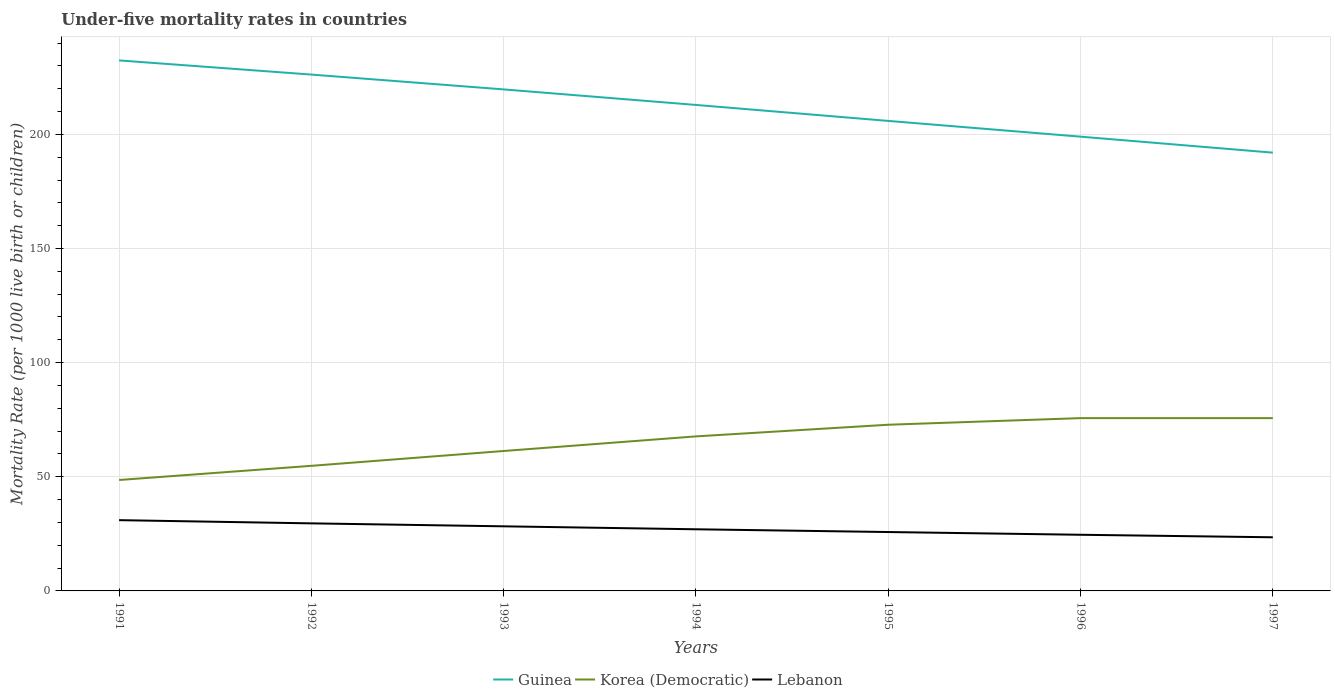How many different coloured lines are there?
Make the answer very short. 3. Does the line corresponding to Lebanon intersect with the line corresponding to Korea (Democratic)?
Provide a succinct answer. No. Across all years, what is the maximum under-five mortality rate in Korea (Democratic)?
Provide a succinct answer. 48.6. What is the total under-five mortality rate in Korea (Democratic) in the graph?
Offer a very short reply. -2.9. What is the difference between the highest and the second highest under-five mortality rate in Guinea?
Your answer should be compact. 40.4. How many years are there in the graph?
Your answer should be very brief. 7. What is the difference between two consecutive major ticks on the Y-axis?
Offer a terse response. 50. Does the graph contain grids?
Your response must be concise. Yes. How are the legend labels stacked?
Your answer should be very brief. Horizontal. What is the title of the graph?
Offer a very short reply. Under-five mortality rates in countries. Does "Cyprus" appear as one of the legend labels in the graph?
Keep it short and to the point. No. What is the label or title of the Y-axis?
Your response must be concise. Mortality Rate (per 1000 live birth or children). What is the Mortality Rate (per 1000 live birth or children) of Guinea in 1991?
Ensure brevity in your answer.  232.4. What is the Mortality Rate (per 1000 live birth or children) of Korea (Democratic) in 1991?
Make the answer very short. 48.6. What is the Mortality Rate (per 1000 live birth or children) of Guinea in 1992?
Provide a succinct answer. 226.2. What is the Mortality Rate (per 1000 live birth or children) of Korea (Democratic) in 1992?
Your answer should be very brief. 54.8. What is the Mortality Rate (per 1000 live birth or children) of Lebanon in 1992?
Provide a short and direct response. 29.6. What is the Mortality Rate (per 1000 live birth or children) of Guinea in 1993?
Make the answer very short. 219.7. What is the Mortality Rate (per 1000 live birth or children) of Korea (Democratic) in 1993?
Provide a succinct answer. 61.3. What is the Mortality Rate (per 1000 live birth or children) of Lebanon in 1993?
Provide a short and direct response. 28.3. What is the Mortality Rate (per 1000 live birth or children) in Guinea in 1994?
Provide a short and direct response. 212.9. What is the Mortality Rate (per 1000 live birth or children) in Korea (Democratic) in 1994?
Provide a short and direct response. 67.7. What is the Mortality Rate (per 1000 live birth or children) in Lebanon in 1994?
Keep it short and to the point. 27. What is the Mortality Rate (per 1000 live birth or children) in Guinea in 1995?
Your answer should be very brief. 205.9. What is the Mortality Rate (per 1000 live birth or children) in Korea (Democratic) in 1995?
Offer a terse response. 72.8. What is the Mortality Rate (per 1000 live birth or children) of Lebanon in 1995?
Ensure brevity in your answer.  25.8. What is the Mortality Rate (per 1000 live birth or children) of Guinea in 1996?
Offer a very short reply. 199. What is the Mortality Rate (per 1000 live birth or children) in Korea (Democratic) in 1996?
Offer a terse response. 75.7. What is the Mortality Rate (per 1000 live birth or children) of Lebanon in 1996?
Your answer should be very brief. 24.6. What is the Mortality Rate (per 1000 live birth or children) of Guinea in 1997?
Provide a succinct answer. 192. What is the Mortality Rate (per 1000 live birth or children) of Korea (Democratic) in 1997?
Provide a short and direct response. 75.7. What is the Mortality Rate (per 1000 live birth or children) in Lebanon in 1997?
Make the answer very short. 23.5. Across all years, what is the maximum Mortality Rate (per 1000 live birth or children) in Guinea?
Offer a terse response. 232.4. Across all years, what is the maximum Mortality Rate (per 1000 live birth or children) in Korea (Democratic)?
Your response must be concise. 75.7. Across all years, what is the maximum Mortality Rate (per 1000 live birth or children) in Lebanon?
Keep it short and to the point. 31. Across all years, what is the minimum Mortality Rate (per 1000 live birth or children) of Guinea?
Offer a terse response. 192. Across all years, what is the minimum Mortality Rate (per 1000 live birth or children) of Korea (Democratic)?
Your response must be concise. 48.6. Across all years, what is the minimum Mortality Rate (per 1000 live birth or children) in Lebanon?
Make the answer very short. 23.5. What is the total Mortality Rate (per 1000 live birth or children) in Guinea in the graph?
Ensure brevity in your answer.  1488.1. What is the total Mortality Rate (per 1000 live birth or children) in Korea (Democratic) in the graph?
Ensure brevity in your answer.  456.6. What is the total Mortality Rate (per 1000 live birth or children) of Lebanon in the graph?
Keep it short and to the point. 189.8. What is the difference between the Mortality Rate (per 1000 live birth or children) in Guinea in 1991 and that in 1992?
Your answer should be compact. 6.2. What is the difference between the Mortality Rate (per 1000 live birth or children) of Lebanon in 1991 and that in 1992?
Your answer should be compact. 1.4. What is the difference between the Mortality Rate (per 1000 live birth or children) in Guinea in 1991 and that in 1993?
Offer a very short reply. 12.7. What is the difference between the Mortality Rate (per 1000 live birth or children) of Korea (Democratic) in 1991 and that in 1993?
Keep it short and to the point. -12.7. What is the difference between the Mortality Rate (per 1000 live birth or children) of Lebanon in 1991 and that in 1993?
Give a very brief answer. 2.7. What is the difference between the Mortality Rate (per 1000 live birth or children) in Guinea in 1991 and that in 1994?
Offer a terse response. 19.5. What is the difference between the Mortality Rate (per 1000 live birth or children) of Korea (Democratic) in 1991 and that in 1994?
Ensure brevity in your answer.  -19.1. What is the difference between the Mortality Rate (per 1000 live birth or children) of Korea (Democratic) in 1991 and that in 1995?
Your answer should be compact. -24.2. What is the difference between the Mortality Rate (per 1000 live birth or children) in Lebanon in 1991 and that in 1995?
Provide a short and direct response. 5.2. What is the difference between the Mortality Rate (per 1000 live birth or children) in Guinea in 1991 and that in 1996?
Keep it short and to the point. 33.4. What is the difference between the Mortality Rate (per 1000 live birth or children) of Korea (Democratic) in 1991 and that in 1996?
Provide a succinct answer. -27.1. What is the difference between the Mortality Rate (per 1000 live birth or children) of Guinea in 1991 and that in 1997?
Offer a terse response. 40.4. What is the difference between the Mortality Rate (per 1000 live birth or children) in Korea (Democratic) in 1991 and that in 1997?
Offer a terse response. -27.1. What is the difference between the Mortality Rate (per 1000 live birth or children) in Guinea in 1992 and that in 1993?
Provide a succinct answer. 6.5. What is the difference between the Mortality Rate (per 1000 live birth or children) of Korea (Democratic) in 1992 and that in 1993?
Your response must be concise. -6.5. What is the difference between the Mortality Rate (per 1000 live birth or children) in Lebanon in 1992 and that in 1993?
Your response must be concise. 1.3. What is the difference between the Mortality Rate (per 1000 live birth or children) of Guinea in 1992 and that in 1994?
Ensure brevity in your answer.  13.3. What is the difference between the Mortality Rate (per 1000 live birth or children) in Lebanon in 1992 and that in 1994?
Your answer should be compact. 2.6. What is the difference between the Mortality Rate (per 1000 live birth or children) of Guinea in 1992 and that in 1995?
Ensure brevity in your answer.  20.3. What is the difference between the Mortality Rate (per 1000 live birth or children) of Korea (Democratic) in 1992 and that in 1995?
Provide a succinct answer. -18. What is the difference between the Mortality Rate (per 1000 live birth or children) of Lebanon in 1992 and that in 1995?
Offer a very short reply. 3.8. What is the difference between the Mortality Rate (per 1000 live birth or children) in Guinea in 1992 and that in 1996?
Offer a terse response. 27.2. What is the difference between the Mortality Rate (per 1000 live birth or children) in Korea (Democratic) in 1992 and that in 1996?
Keep it short and to the point. -20.9. What is the difference between the Mortality Rate (per 1000 live birth or children) of Lebanon in 1992 and that in 1996?
Keep it short and to the point. 5. What is the difference between the Mortality Rate (per 1000 live birth or children) of Guinea in 1992 and that in 1997?
Offer a very short reply. 34.2. What is the difference between the Mortality Rate (per 1000 live birth or children) in Korea (Democratic) in 1992 and that in 1997?
Your response must be concise. -20.9. What is the difference between the Mortality Rate (per 1000 live birth or children) of Lebanon in 1992 and that in 1997?
Give a very brief answer. 6.1. What is the difference between the Mortality Rate (per 1000 live birth or children) in Korea (Democratic) in 1993 and that in 1994?
Offer a terse response. -6.4. What is the difference between the Mortality Rate (per 1000 live birth or children) in Guinea in 1993 and that in 1995?
Your answer should be compact. 13.8. What is the difference between the Mortality Rate (per 1000 live birth or children) in Korea (Democratic) in 1993 and that in 1995?
Give a very brief answer. -11.5. What is the difference between the Mortality Rate (per 1000 live birth or children) of Guinea in 1993 and that in 1996?
Offer a very short reply. 20.7. What is the difference between the Mortality Rate (per 1000 live birth or children) of Korea (Democratic) in 1993 and that in 1996?
Ensure brevity in your answer.  -14.4. What is the difference between the Mortality Rate (per 1000 live birth or children) in Guinea in 1993 and that in 1997?
Provide a short and direct response. 27.7. What is the difference between the Mortality Rate (per 1000 live birth or children) of Korea (Democratic) in 1993 and that in 1997?
Your answer should be compact. -14.4. What is the difference between the Mortality Rate (per 1000 live birth or children) in Guinea in 1994 and that in 1996?
Offer a terse response. 13.9. What is the difference between the Mortality Rate (per 1000 live birth or children) of Lebanon in 1994 and that in 1996?
Your response must be concise. 2.4. What is the difference between the Mortality Rate (per 1000 live birth or children) of Guinea in 1994 and that in 1997?
Give a very brief answer. 20.9. What is the difference between the Mortality Rate (per 1000 live birth or children) of Lebanon in 1994 and that in 1997?
Give a very brief answer. 3.5. What is the difference between the Mortality Rate (per 1000 live birth or children) of Korea (Democratic) in 1995 and that in 1997?
Keep it short and to the point. -2.9. What is the difference between the Mortality Rate (per 1000 live birth or children) in Guinea in 1996 and that in 1997?
Your answer should be compact. 7. What is the difference between the Mortality Rate (per 1000 live birth or children) of Guinea in 1991 and the Mortality Rate (per 1000 live birth or children) of Korea (Democratic) in 1992?
Your response must be concise. 177.6. What is the difference between the Mortality Rate (per 1000 live birth or children) in Guinea in 1991 and the Mortality Rate (per 1000 live birth or children) in Lebanon in 1992?
Ensure brevity in your answer.  202.8. What is the difference between the Mortality Rate (per 1000 live birth or children) in Guinea in 1991 and the Mortality Rate (per 1000 live birth or children) in Korea (Democratic) in 1993?
Your answer should be very brief. 171.1. What is the difference between the Mortality Rate (per 1000 live birth or children) in Guinea in 1991 and the Mortality Rate (per 1000 live birth or children) in Lebanon in 1993?
Make the answer very short. 204.1. What is the difference between the Mortality Rate (per 1000 live birth or children) in Korea (Democratic) in 1991 and the Mortality Rate (per 1000 live birth or children) in Lebanon in 1993?
Ensure brevity in your answer.  20.3. What is the difference between the Mortality Rate (per 1000 live birth or children) in Guinea in 1991 and the Mortality Rate (per 1000 live birth or children) in Korea (Democratic) in 1994?
Your response must be concise. 164.7. What is the difference between the Mortality Rate (per 1000 live birth or children) of Guinea in 1991 and the Mortality Rate (per 1000 live birth or children) of Lebanon in 1994?
Provide a succinct answer. 205.4. What is the difference between the Mortality Rate (per 1000 live birth or children) of Korea (Democratic) in 1991 and the Mortality Rate (per 1000 live birth or children) of Lebanon in 1994?
Provide a succinct answer. 21.6. What is the difference between the Mortality Rate (per 1000 live birth or children) in Guinea in 1991 and the Mortality Rate (per 1000 live birth or children) in Korea (Democratic) in 1995?
Offer a very short reply. 159.6. What is the difference between the Mortality Rate (per 1000 live birth or children) of Guinea in 1991 and the Mortality Rate (per 1000 live birth or children) of Lebanon in 1995?
Provide a succinct answer. 206.6. What is the difference between the Mortality Rate (per 1000 live birth or children) of Korea (Democratic) in 1991 and the Mortality Rate (per 1000 live birth or children) of Lebanon in 1995?
Your response must be concise. 22.8. What is the difference between the Mortality Rate (per 1000 live birth or children) in Guinea in 1991 and the Mortality Rate (per 1000 live birth or children) in Korea (Democratic) in 1996?
Offer a terse response. 156.7. What is the difference between the Mortality Rate (per 1000 live birth or children) of Guinea in 1991 and the Mortality Rate (per 1000 live birth or children) of Lebanon in 1996?
Offer a terse response. 207.8. What is the difference between the Mortality Rate (per 1000 live birth or children) of Korea (Democratic) in 1991 and the Mortality Rate (per 1000 live birth or children) of Lebanon in 1996?
Provide a succinct answer. 24. What is the difference between the Mortality Rate (per 1000 live birth or children) of Guinea in 1991 and the Mortality Rate (per 1000 live birth or children) of Korea (Democratic) in 1997?
Offer a terse response. 156.7. What is the difference between the Mortality Rate (per 1000 live birth or children) of Guinea in 1991 and the Mortality Rate (per 1000 live birth or children) of Lebanon in 1997?
Make the answer very short. 208.9. What is the difference between the Mortality Rate (per 1000 live birth or children) in Korea (Democratic) in 1991 and the Mortality Rate (per 1000 live birth or children) in Lebanon in 1997?
Make the answer very short. 25.1. What is the difference between the Mortality Rate (per 1000 live birth or children) in Guinea in 1992 and the Mortality Rate (per 1000 live birth or children) in Korea (Democratic) in 1993?
Provide a succinct answer. 164.9. What is the difference between the Mortality Rate (per 1000 live birth or children) in Guinea in 1992 and the Mortality Rate (per 1000 live birth or children) in Lebanon in 1993?
Provide a succinct answer. 197.9. What is the difference between the Mortality Rate (per 1000 live birth or children) in Korea (Democratic) in 1992 and the Mortality Rate (per 1000 live birth or children) in Lebanon in 1993?
Provide a short and direct response. 26.5. What is the difference between the Mortality Rate (per 1000 live birth or children) in Guinea in 1992 and the Mortality Rate (per 1000 live birth or children) in Korea (Democratic) in 1994?
Ensure brevity in your answer.  158.5. What is the difference between the Mortality Rate (per 1000 live birth or children) in Guinea in 1992 and the Mortality Rate (per 1000 live birth or children) in Lebanon in 1994?
Provide a short and direct response. 199.2. What is the difference between the Mortality Rate (per 1000 live birth or children) in Korea (Democratic) in 1992 and the Mortality Rate (per 1000 live birth or children) in Lebanon in 1994?
Give a very brief answer. 27.8. What is the difference between the Mortality Rate (per 1000 live birth or children) in Guinea in 1992 and the Mortality Rate (per 1000 live birth or children) in Korea (Democratic) in 1995?
Your answer should be compact. 153.4. What is the difference between the Mortality Rate (per 1000 live birth or children) in Guinea in 1992 and the Mortality Rate (per 1000 live birth or children) in Lebanon in 1995?
Provide a succinct answer. 200.4. What is the difference between the Mortality Rate (per 1000 live birth or children) of Guinea in 1992 and the Mortality Rate (per 1000 live birth or children) of Korea (Democratic) in 1996?
Make the answer very short. 150.5. What is the difference between the Mortality Rate (per 1000 live birth or children) of Guinea in 1992 and the Mortality Rate (per 1000 live birth or children) of Lebanon in 1996?
Keep it short and to the point. 201.6. What is the difference between the Mortality Rate (per 1000 live birth or children) in Korea (Democratic) in 1992 and the Mortality Rate (per 1000 live birth or children) in Lebanon in 1996?
Make the answer very short. 30.2. What is the difference between the Mortality Rate (per 1000 live birth or children) of Guinea in 1992 and the Mortality Rate (per 1000 live birth or children) of Korea (Democratic) in 1997?
Give a very brief answer. 150.5. What is the difference between the Mortality Rate (per 1000 live birth or children) in Guinea in 1992 and the Mortality Rate (per 1000 live birth or children) in Lebanon in 1997?
Your answer should be compact. 202.7. What is the difference between the Mortality Rate (per 1000 live birth or children) in Korea (Democratic) in 1992 and the Mortality Rate (per 1000 live birth or children) in Lebanon in 1997?
Provide a succinct answer. 31.3. What is the difference between the Mortality Rate (per 1000 live birth or children) of Guinea in 1993 and the Mortality Rate (per 1000 live birth or children) of Korea (Democratic) in 1994?
Offer a terse response. 152. What is the difference between the Mortality Rate (per 1000 live birth or children) of Guinea in 1993 and the Mortality Rate (per 1000 live birth or children) of Lebanon in 1994?
Your answer should be very brief. 192.7. What is the difference between the Mortality Rate (per 1000 live birth or children) in Korea (Democratic) in 1993 and the Mortality Rate (per 1000 live birth or children) in Lebanon in 1994?
Your answer should be compact. 34.3. What is the difference between the Mortality Rate (per 1000 live birth or children) in Guinea in 1993 and the Mortality Rate (per 1000 live birth or children) in Korea (Democratic) in 1995?
Keep it short and to the point. 146.9. What is the difference between the Mortality Rate (per 1000 live birth or children) of Guinea in 1993 and the Mortality Rate (per 1000 live birth or children) of Lebanon in 1995?
Ensure brevity in your answer.  193.9. What is the difference between the Mortality Rate (per 1000 live birth or children) of Korea (Democratic) in 1993 and the Mortality Rate (per 1000 live birth or children) of Lebanon in 1995?
Your answer should be compact. 35.5. What is the difference between the Mortality Rate (per 1000 live birth or children) of Guinea in 1993 and the Mortality Rate (per 1000 live birth or children) of Korea (Democratic) in 1996?
Your answer should be compact. 144. What is the difference between the Mortality Rate (per 1000 live birth or children) of Guinea in 1993 and the Mortality Rate (per 1000 live birth or children) of Lebanon in 1996?
Make the answer very short. 195.1. What is the difference between the Mortality Rate (per 1000 live birth or children) in Korea (Democratic) in 1993 and the Mortality Rate (per 1000 live birth or children) in Lebanon in 1996?
Ensure brevity in your answer.  36.7. What is the difference between the Mortality Rate (per 1000 live birth or children) of Guinea in 1993 and the Mortality Rate (per 1000 live birth or children) of Korea (Democratic) in 1997?
Your response must be concise. 144. What is the difference between the Mortality Rate (per 1000 live birth or children) of Guinea in 1993 and the Mortality Rate (per 1000 live birth or children) of Lebanon in 1997?
Provide a short and direct response. 196.2. What is the difference between the Mortality Rate (per 1000 live birth or children) in Korea (Democratic) in 1993 and the Mortality Rate (per 1000 live birth or children) in Lebanon in 1997?
Make the answer very short. 37.8. What is the difference between the Mortality Rate (per 1000 live birth or children) of Guinea in 1994 and the Mortality Rate (per 1000 live birth or children) of Korea (Democratic) in 1995?
Ensure brevity in your answer.  140.1. What is the difference between the Mortality Rate (per 1000 live birth or children) in Guinea in 1994 and the Mortality Rate (per 1000 live birth or children) in Lebanon in 1995?
Provide a succinct answer. 187.1. What is the difference between the Mortality Rate (per 1000 live birth or children) of Korea (Democratic) in 1994 and the Mortality Rate (per 1000 live birth or children) of Lebanon in 1995?
Your answer should be very brief. 41.9. What is the difference between the Mortality Rate (per 1000 live birth or children) of Guinea in 1994 and the Mortality Rate (per 1000 live birth or children) of Korea (Democratic) in 1996?
Offer a very short reply. 137.2. What is the difference between the Mortality Rate (per 1000 live birth or children) in Guinea in 1994 and the Mortality Rate (per 1000 live birth or children) in Lebanon in 1996?
Offer a terse response. 188.3. What is the difference between the Mortality Rate (per 1000 live birth or children) in Korea (Democratic) in 1994 and the Mortality Rate (per 1000 live birth or children) in Lebanon in 1996?
Make the answer very short. 43.1. What is the difference between the Mortality Rate (per 1000 live birth or children) of Guinea in 1994 and the Mortality Rate (per 1000 live birth or children) of Korea (Democratic) in 1997?
Give a very brief answer. 137.2. What is the difference between the Mortality Rate (per 1000 live birth or children) of Guinea in 1994 and the Mortality Rate (per 1000 live birth or children) of Lebanon in 1997?
Your response must be concise. 189.4. What is the difference between the Mortality Rate (per 1000 live birth or children) in Korea (Democratic) in 1994 and the Mortality Rate (per 1000 live birth or children) in Lebanon in 1997?
Provide a short and direct response. 44.2. What is the difference between the Mortality Rate (per 1000 live birth or children) of Guinea in 1995 and the Mortality Rate (per 1000 live birth or children) of Korea (Democratic) in 1996?
Provide a succinct answer. 130.2. What is the difference between the Mortality Rate (per 1000 live birth or children) of Guinea in 1995 and the Mortality Rate (per 1000 live birth or children) of Lebanon in 1996?
Keep it short and to the point. 181.3. What is the difference between the Mortality Rate (per 1000 live birth or children) in Korea (Democratic) in 1995 and the Mortality Rate (per 1000 live birth or children) in Lebanon in 1996?
Ensure brevity in your answer.  48.2. What is the difference between the Mortality Rate (per 1000 live birth or children) of Guinea in 1995 and the Mortality Rate (per 1000 live birth or children) of Korea (Democratic) in 1997?
Provide a short and direct response. 130.2. What is the difference between the Mortality Rate (per 1000 live birth or children) of Guinea in 1995 and the Mortality Rate (per 1000 live birth or children) of Lebanon in 1997?
Keep it short and to the point. 182.4. What is the difference between the Mortality Rate (per 1000 live birth or children) of Korea (Democratic) in 1995 and the Mortality Rate (per 1000 live birth or children) of Lebanon in 1997?
Keep it short and to the point. 49.3. What is the difference between the Mortality Rate (per 1000 live birth or children) in Guinea in 1996 and the Mortality Rate (per 1000 live birth or children) in Korea (Democratic) in 1997?
Provide a succinct answer. 123.3. What is the difference between the Mortality Rate (per 1000 live birth or children) of Guinea in 1996 and the Mortality Rate (per 1000 live birth or children) of Lebanon in 1997?
Your response must be concise. 175.5. What is the difference between the Mortality Rate (per 1000 live birth or children) in Korea (Democratic) in 1996 and the Mortality Rate (per 1000 live birth or children) in Lebanon in 1997?
Ensure brevity in your answer.  52.2. What is the average Mortality Rate (per 1000 live birth or children) of Guinea per year?
Offer a terse response. 212.59. What is the average Mortality Rate (per 1000 live birth or children) of Korea (Democratic) per year?
Ensure brevity in your answer.  65.23. What is the average Mortality Rate (per 1000 live birth or children) of Lebanon per year?
Offer a terse response. 27.11. In the year 1991, what is the difference between the Mortality Rate (per 1000 live birth or children) of Guinea and Mortality Rate (per 1000 live birth or children) of Korea (Democratic)?
Provide a succinct answer. 183.8. In the year 1991, what is the difference between the Mortality Rate (per 1000 live birth or children) in Guinea and Mortality Rate (per 1000 live birth or children) in Lebanon?
Provide a short and direct response. 201.4. In the year 1991, what is the difference between the Mortality Rate (per 1000 live birth or children) in Korea (Democratic) and Mortality Rate (per 1000 live birth or children) in Lebanon?
Give a very brief answer. 17.6. In the year 1992, what is the difference between the Mortality Rate (per 1000 live birth or children) of Guinea and Mortality Rate (per 1000 live birth or children) of Korea (Democratic)?
Provide a short and direct response. 171.4. In the year 1992, what is the difference between the Mortality Rate (per 1000 live birth or children) in Guinea and Mortality Rate (per 1000 live birth or children) in Lebanon?
Your response must be concise. 196.6. In the year 1992, what is the difference between the Mortality Rate (per 1000 live birth or children) in Korea (Democratic) and Mortality Rate (per 1000 live birth or children) in Lebanon?
Your answer should be very brief. 25.2. In the year 1993, what is the difference between the Mortality Rate (per 1000 live birth or children) of Guinea and Mortality Rate (per 1000 live birth or children) of Korea (Democratic)?
Your response must be concise. 158.4. In the year 1993, what is the difference between the Mortality Rate (per 1000 live birth or children) in Guinea and Mortality Rate (per 1000 live birth or children) in Lebanon?
Give a very brief answer. 191.4. In the year 1993, what is the difference between the Mortality Rate (per 1000 live birth or children) of Korea (Democratic) and Mortality Rate (per 1000 live birth or children) of Lebanon?
Your response must be concise. 33. In the year 1994, what is the difference between the Mortality Rate (per 1000 live birth or children) of Guinea and Mortality Rate (per 1000 live birth or children) of Korea (Democratic)?
Give a very brief answer. 145.2. In the year 1994, what is the difference between the Mortality Rate (per 1000 live birth or children) in Guinea and Mortality Rate (per 1000 live birth or children) in Lebanon?
Your answer should be compact. 185.9. In the year 1994, what is the difference between the Mortality Rate (per 1000 live birth or children) of Korea (Democratic) and Mortality Rate (per 1000 live birth or children) of Lebanon?
Offer a terse response. 40.7. In the year 1995, what is the difference between the Mortality Rate (per 1000 live birth or children) in Guinea and Mortality Rate (per 1000 live birth or children) in Korea (Democratic)?
Offer a terse response. 133.1. In the year 1995, what is the difference between the Mortality Rate (per 1000 live birth or children) of Guinea and Mortality Rate (per 1000 live birth or children) of Lebanon?
Provide a short and direct response. 180.1. In the year 1996, what is the difference between the Mortality Rate (per 1000 live birth or children) in Guinea and Mortality Rate (per 1000 live birth or children) in Korea (Democratic)?
Give a very brief answer. 123.3. In the year 1996, what is the difference between the Mortality Rate (per 1000 live birth or children) of Guinea and Mortality Rate (per 1000 live birth or children) of Lebanon?
Keep it short and to the point. 174.4. In the year 1996, what is the difference between the Mortality Rate (per 1000 live birth or children) in Korea (Democratic) and Mortality Rate (per 1000 live birth or children) in Lebanon?
Your answer should be compact. 51.1. In the year 1997, what is the difference between the Mortality Rate (per 1000 live birth or children) in Guinea and Mortality Rate (per 1000 live birth or children) in Korea (Democratic)?
Your answer should be very brief. 116.3. In the year 1997, what is the difference between the Mortality Rate (per 1000 live birth or children) of Guinea and Mortality Rate (per 1000 live birth or children) of Lebanon?
Your answer should be compact. 168.5. In the year 1997, what is the difference between the Mortality Rate (per 1000 live birth or children) in Korea (Democratic) and Mortality Rate (per 1000 live birth or children) in Lebanon?
Your answer should be compact. 52.2. What is the ratio of the Mortality Rate (per 1000 live birth or children) in Guinea in 1991 to that in 1992?
Give a very brief answer. 1.03. What is the ratio of the Mortality Rate (per 1000 live birth or children) of Korea (Democratic) in 1991 to that in 1992?
Give a very brief answer. 0.89. What is the ratio of the Mortality Rate (per 1000 live birth or children) of Lebanon in 1991 to that in 1992?
Keep it short and to the point. 1.05. What is the ratio of the Mortality Rate (per 1000 live birth or children) of Guinea in 1991 to that in 1993?
Offer a terse response. 1.06. What is the ratio of the Mortality Rate (per 1000 live birth or children) in Korea (Democratic) in 1991 to that in 1993?
Give a very brief answer. 0.79. What is the ratio of the Mortality Rate (per 1000 live birth or children) in Lebanon in 1991 to that in 1993?
Provide a short and direct response. 1.1. What is the ratio of the Mortality Rate (per 1000 live birth or children) of Guinea in 1991 to that in 1994?
Your response must be concise. 1.09. What is the ratio of the Mortality Rate (per 1000 live birth or children) of Korea (Democratic) in 1991 to that in 1994?
Your response must be concise. 0.72. What is the ratio of the Mortality Rate (per 1000 live birth or children) of Lebanon in 1991 to that in 1994?
Keep it short and to the point. 1.15. What is the ratio of the Mortality Rate (per 1000 live birth or children) of Guinea in 1991 to that in 1995?
Keep it short and to the point. 1.13. What is the ratio of the Mortality Rate (per 1000 live birth or children) of Korea (Democratic) in 1991 to that in 1995?
Give a very brief answer. 0.67. What is the ratio of the Mortality Rate (per 1000 live birth or children) in Lebanon in 1991 to that in 1995?
Make the answer very short. 1.2. What is the ratio of the Mortality Rate (per 1000 live birth or children) in Guinea in 1991 to that in 1996?
Make the answer very short. 1.17. What is the ratio of the Mortality Rate (per 1000 live birth or children) of Korea (Democratic) in 1991 to that in 1996?
Provide a short and direct response. 0.64. What is the ratio of the Mortality Rate (per 1000 live birth or children) in Lebanon in 1991 to that in 1996?
Provide a succinct answer. 1.26. What is the ratio of the Mortality Rate (per 1000 live birth or children) in Guinea in 1991 to that in 1997?
Your answer should be compact. 1.21. What is the ratio of the Mortality Rate (per 1000 live birth or children) in Korea (Democratic) in 1991 to that in 1997?
Keep it short and to the point. 0.64. What is the ratio of the Mortality Rate (per 1000 live birth or children) of Lebanon in 1991 to that in 1997?
Give a very brief answer. 1.32. What is the ratio of the Mortality Rate (per 1000 live birth or children) of Guinea in 1992 to that in 1993?
Offer a terse response. 1.03. What is the ratio of the Mortality Rate (per 1000 live birth or children) in Korea (Democratic) in 1992 to that in 1993?
Provide a short and direct response. 0.89. What is the ratio of the Mortality Rate (per 1000 live birth or children) of Lebanon in 1992 to that in 1993?
Offer a very short reply. 1.05. What is the ratio of the Mortality Rate (per 1000 live birth or children) of Korea (Democratic) in 1992 to that in 1994?
Provide a short and direct response. 0.81. What is the ratio of the Mortality Rate (per 1000 live birth or children) in Lebanon in 1992 to that in 1994?
Your answer should be very brief. 1.1. What is the ratio of the Mortality Rate (per 1000 live birth or children) of Guinea in 1992 to that in 1995?
Your answer should be compact. 1.1. What is the ratio of the Mortality Rate (per 1000 live birth or children) of Korea (Democratic) in 1992 to that in 1995?
Make the answer very short. 0.75. What is the ratio of the Mortality Rate (per 1000 live birth or children) of Lebanon in 1992 to that in 1995?
Your answer should be very brief. 1.15. What is the ratio of the Mortality Rate (per 1000 live birth or children) in Guinea in 1992 to that in 1996?
Provide a short and direct response. 1.14. What is the ratio of the Mortality Rate (per 1000 live birth or children) in Korea (Democratic) in 1992 to that in 1996?
Your answer should be very brief. 0.72. What is the ratio of the Mortality Rate (per 1000 live birth or children) of Lebanon in 1992 to that in 1996?
Offer a terse response. 1.2. What is the ratio of the Mortality Rate (per 1000 live birth or children) in Guinea in 1992 to that in 1997?
Offer a terse response. 1.18. What is the ratio of the Mortality Rate (per 1000 live birth or children) in Korea (Democratic) in 1992 to that in 1997?
Give a very brief answer. 0.72. What is the ratio of the Mortality Rate (per 1000 live birth or children) of Lebanon in 1992 to that in 1997?
Your answer should be very brief. 1.26. What is the ratio of the Mortality Rate (per 1000 live birth or children) in Guinea in 1993 to that in 1994?
Your response must be concise. 1.03. What is the ratio of the Mortality Rate (per 1000 live birth or children) of Korea (Democratic) in 1993 to that in 1994?
Offer a terse response. 0.91. What is the ratio of the Mortality Rate (per 1000 live birth or children) in Lebanon in 1993 to that in 1994?
Keep it short and to the point. 1.05. What is the ratio of the Mortality Rate (per 1000 live birth or children) in Guinea in 1993 to that in 1995?
Keep it short and to the point. 1.07. What is the ratio of the Mortality Rate (per 1000 live birth or children) of Korea (Democratic) in 1993 to that in 1995?
Offer a very short reply. 0.84. What is the ratio of the Mortality Rate (per 1000 live birth or children) of Lebanon in 1993 to that in 1995?
Keep it short and to the point. 1.1. What is the ratio of the Mortality Rate (per 1000 live birth or children) of Guinea in 1993 to that in 1996?
Keep it short and to the point. 1.1. What is the ratio of the Mortality Rate (per 1000 live birth or children) of Korea (Democratic) in 1993 to that in 1996?
Ensure brevity in your answer.  0.81. What is the ratio of the Mortality Rate (per 1000 live birth or children) in Lebanon in 1993 to that in 1996?
Provide a short and direct response. 1.15. What is the ratio of the Mortality Rate (per 1000 live birth or children) of Guinea in 1993 to that in 1997?
Offer a very short reply. 1.14. What is the ratio of the Mortality Rate (per 1000 live birth or children) in Korea (Democratic) in 1993 to that in 1997?
Offer a very short reply. 0.81. What is the ratio of the Mortality Rate (per 1000 live birth or children) of Lebanon in 1993 to that in 1997?
Your answer should be very brief. 1.2. What is the ratio of the Mortality Rate (per 1000 live birth or children) of Guinea in 1994 to that in 1995?
Give a very brief answer. 1.03. What is the ratio of the Mortality Rate (per 1000 live birth or children) in Korea (Democratic) in 1994 to that in 1995?
Your answer should be compact. 0.93. What is the ratio of the Mortality Rate (per 1000 live birth or children) in Lebanon in 1994 to that in 1995?
Your response must be concise. 1.05. What is the ratio of the Mortality Rate (per 1000 live birth or children) of Guinea in 1994 to that in 1996?
Give a very brief answer. 1.07. What is the ratio of the Mortality Rate (per 1000 live birth or children) of Korea (Democratic) in 1994 to that in 1996?
Ensure brevity in your answer.  0.89. What is the ratio of the Mortality Rate (per 1000 live birth or children) in Lebanon in 1994 to that in 1996?
Your response must be concise. 1.1. What is the ratio of the Mortality Rate (per 1000 live birth or children) in Guinea in 1994 to that in 1997?
Ensure brevity in your answer.  1.11. What is the ratio of the Mortality Rate (per 1000 live birth or children) in Korea (Democratic) in 1994 to that in 1997?
Your response must be concise. 0.89. What is the ratio of the Mortality Rate (per 1000 live birth or children) in Lebanon in 1994 to that in 1997?
Keep it short and to the point. 1.15. What is the ratio of the Mortality Rate (per 1000 live birth or children) in Guinea in 1995 to that in 1996?
Give a very brief answer. 1.03. What is the ratio of the Mortality Rate (per 1000 live birth or children) in Korea (Democratic) in 1995 to that in 1996?
Ensure brevity in your answer.  0.96. What is the ratio of the Mortality Rate (per 1000 live birth or children) in Lebanon in 1995 to that in 1996?
Your answer should be compact. 1.05. What is the ratio of the Mortality Rate (per 1000 live birth or children) of Guinea in 1995 to that in 1997?
Your answer should be very brief. 1.07. What is the ratio of the Mortality Rate (per 1000 live birth or children) of Korea (Democratic) in 1995 to that in 1997?
Offer a terse response. 0.96. What is the ratio of the Mortality Rate (per 1000 live birth or children) of Lebanon in 1995 to that in 1997?
Your answer should be very brief. 1.1. What is the ratio of the Mortality Rate (per 1000 live birth or children) of Guinea in 1996 to that in 1997?
Your answer should be very brief. 1.04. What is the ratio of the Mortality Rate (per 1000 live birth or children) in Korea (Democratic) in 1996 to that in 1997?
Give a very brief answer. 1. What is the ratio of the Mortality Rate (per 1000 live birth or children) of Lebanon in 1996 to that in 1997?
Make the answer very short. 1.05. What is the difference between the highest and the second highest Mortality Rate (per 1000 live birth or children) in Guinea?
Keep it short and to the point. 6.2. What is the difference between the highest and the second highest Mortality Rate (per 1000 live birth or children) of Korea (Democratic)?
Provide a short and direct response. 0. What is the difference between the highest and the lowest Mortality Rate (per 1000 live birth or children) of Guinea?
Provide a succinct answer. 40.4. What is the difference between the highest and the lowest Mortality Rate (per 1000 live birth or children) of Korea (Democratic)?
Offer a very short reply. 27.1. What is the difference between the highest and the lowest Mortality Rate (per 1000 live birth or children) of Lebanon?
Your response must be concise. 7.5. 